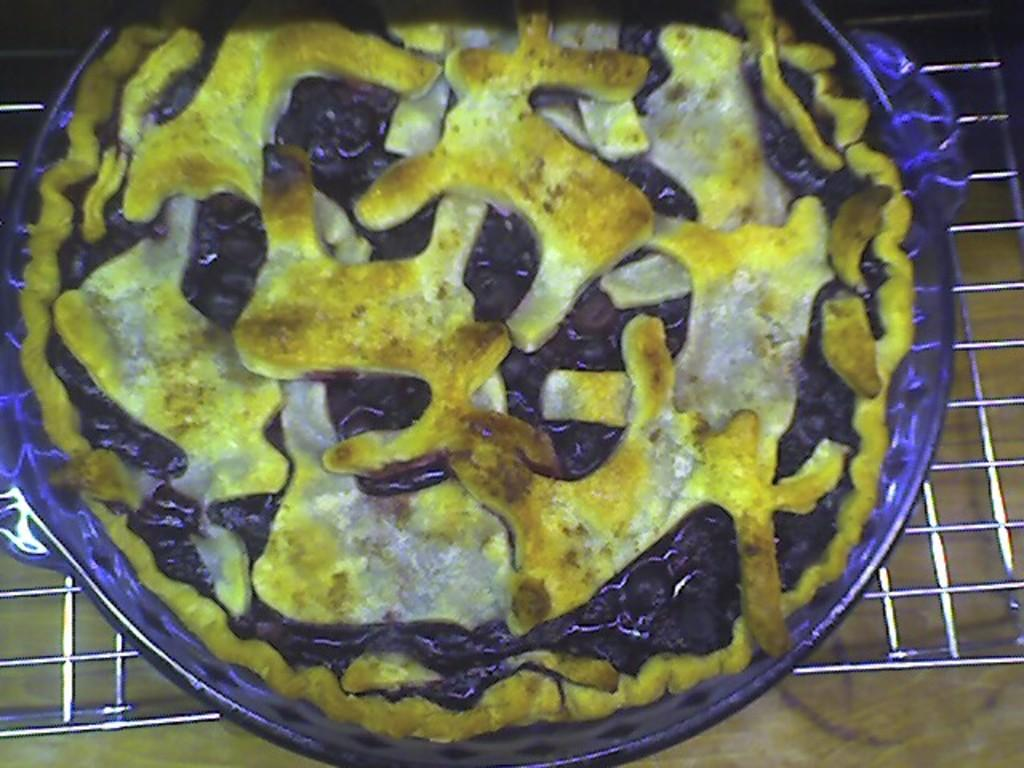What type of food is shown in the image? There is a pizza in the image. How is the pizza being prepared or served? The pizza is on a pan, which is placed on a grill. What type of sink is visible in the image? There is no sink present in the image; it features a pizza on a pan placed on a grill. 